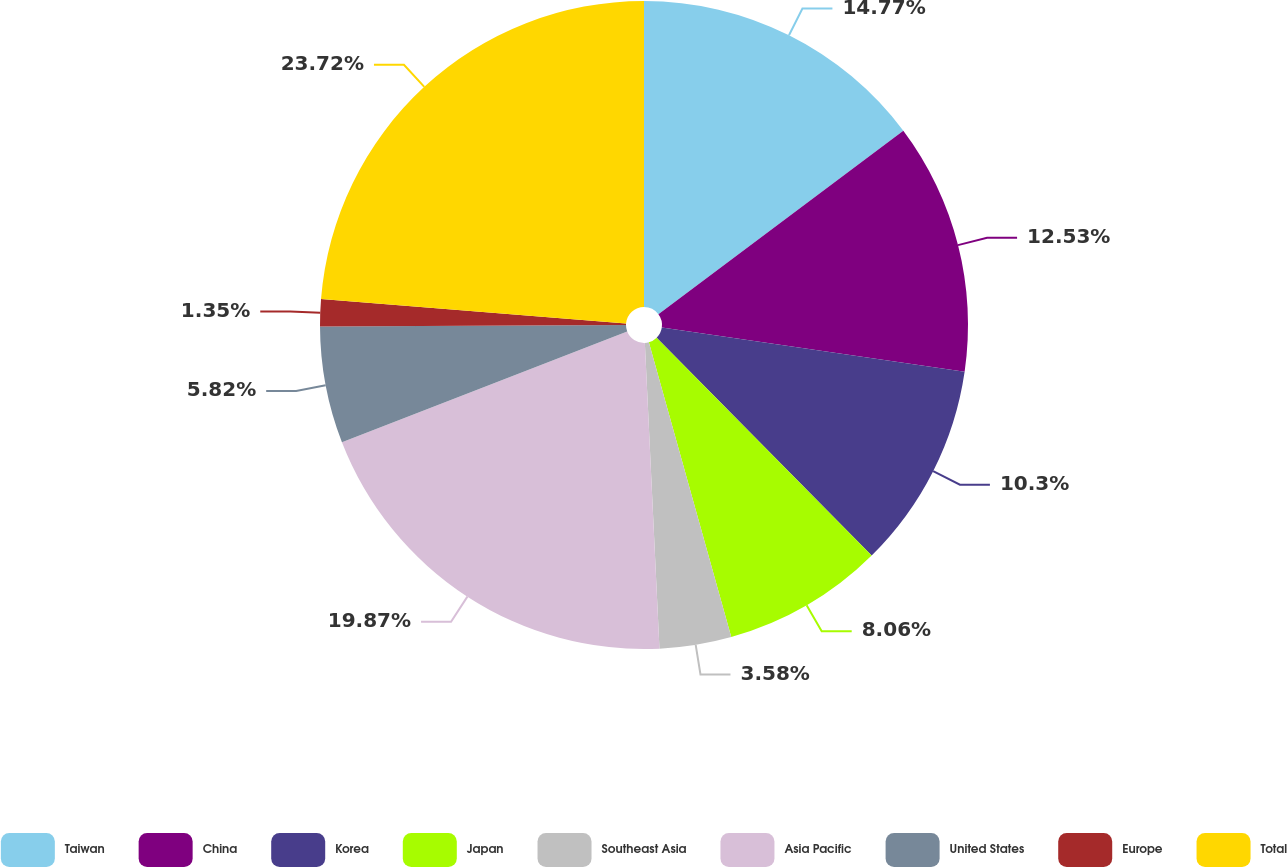Convert chart to OTSL. <chart><loc_0><loc_0><loc_500><loc_500><pie_chart><fcel>Taiwan<fcel>China<fcel>Korea<fcel>Japan<fcel>Southeast Asia<fcel>Asia Pacific<fcel>United States<fcel>Europe<fcel>Total<nl><fcel>14.77%<fcel>12.53%<fcel>10.3%<fcel>8.06%<fcel>3.58%<fcel>19.87%<fcel>5.82%<fcel>1.35%<fcel>23.72%<nl></chart> 